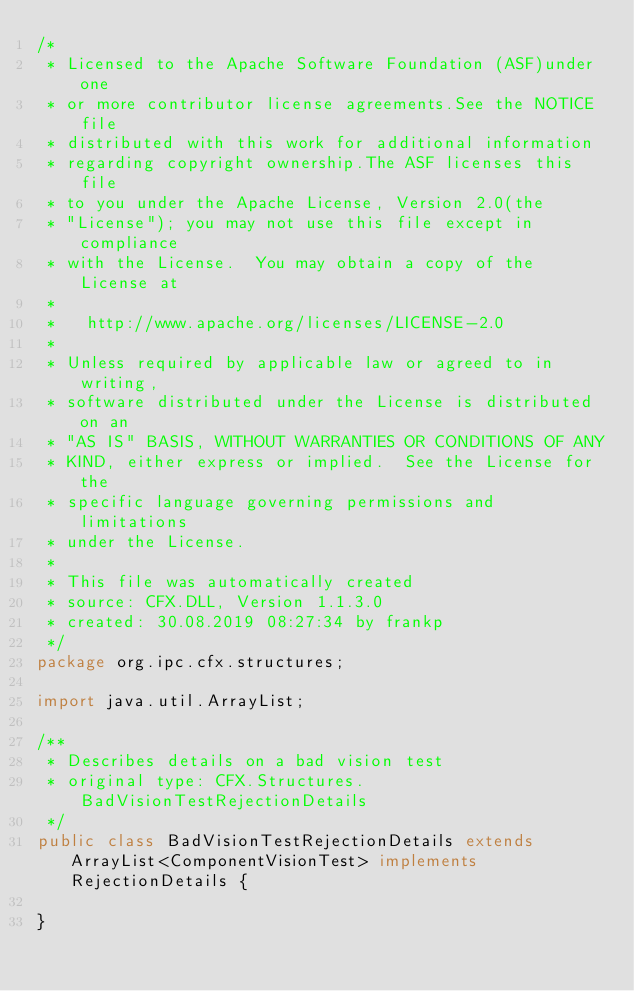Convert code to text. <code><loc_0><loc_0><loc_500><loc_500><_Java_>/*
 * Licensed to the Apache Software Foundation (ASF)under one
 * or more contributor license agreements.See the NOTICE file
 * distributed with this work for additional information
 * regarding copyright ownership.The ASF licenses this file
 * to you under the Apache License, Version 2.0(the
 * "License"); you may not use this file except in compliance
 * with the License.  You may obtain a copy of the License at
 *
 *   http://www.apache.org/licenses/LICENSE-2.0
 *
 * Unless required by applicable law or agreed to in writing,
 * software distributed under the License is distributed on an
 * "AS IS" BASIS, WITHOUT WARRANTIES OR CONDITIONS OF ANY
 * KIND, either express or implied.  See the License for the
 * specific language governing permissions and limitations
 * under the License.
 * 
 * This file was automatically created
 * source: CFX.DLL, Version 1.1.3.0
 * created: 30.08.2019 08:27:34 by frankp
 */
package org.ipc.cfx.structures;

import java.util.ArrayList;

/**
 * Describes details on a bad vision test
 * original type: CFX.Structures.BadVisionTestRejectionDetails
 */
public class BadVisionTestRejectionDetails extends ArrayList<ComponentVisionTest> implements RejectionDetails {

}
</code> 